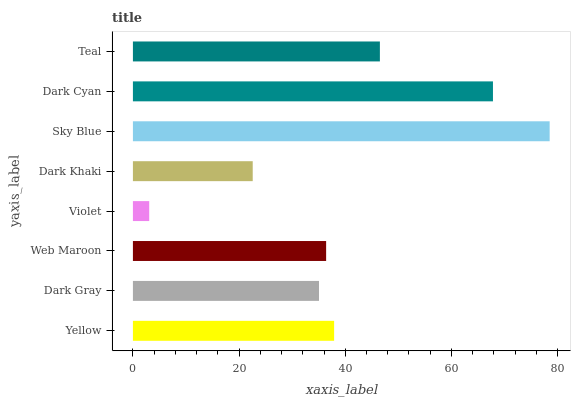Is Violet the minimum?
Answer yes or no. Yes. Is Sky Blue the maximum?
Answer yes or no. Yes. Is Dark Gray the minimum?
Answer yes or no. No. Is Dark Gray the maximum?
Answer yes or no. No. Is Yellow greater than Dark Gray?
Answer yes or no. Yes. Is Dark Gray less than Yellow?
Answer yes or no. Yes. Is Dark Gray greater than Yellow?
Answer yes or no. No. Is Yellow less than Dark Gray?
Answer yes or no. No. Is Yellow the high median?
Answer yes or no. Yes. Is Web Maroon the low median?
Answer yes or no. Yes. Is Dark Gray the high median?
Answer yes or no. No. Is Dark Cyan the low median?
Answer yes or no. No. 